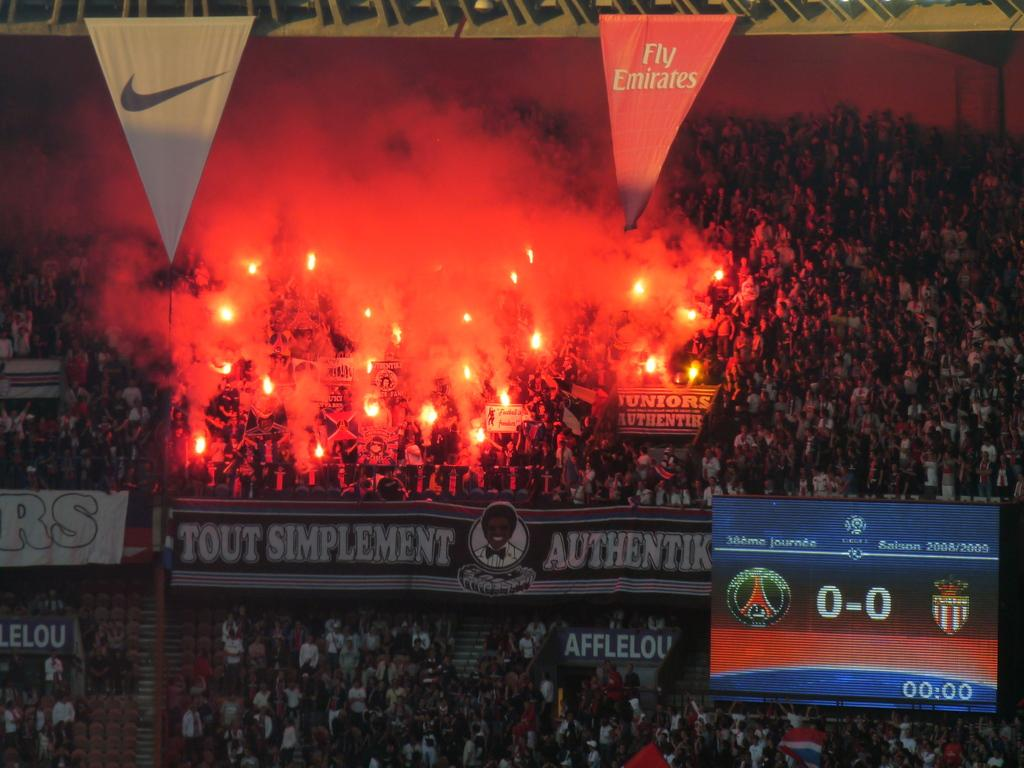<image>
Render a clear and concise summary of the photo. A stadium section full of fans with flare with a banner for fly emirates on the top. 